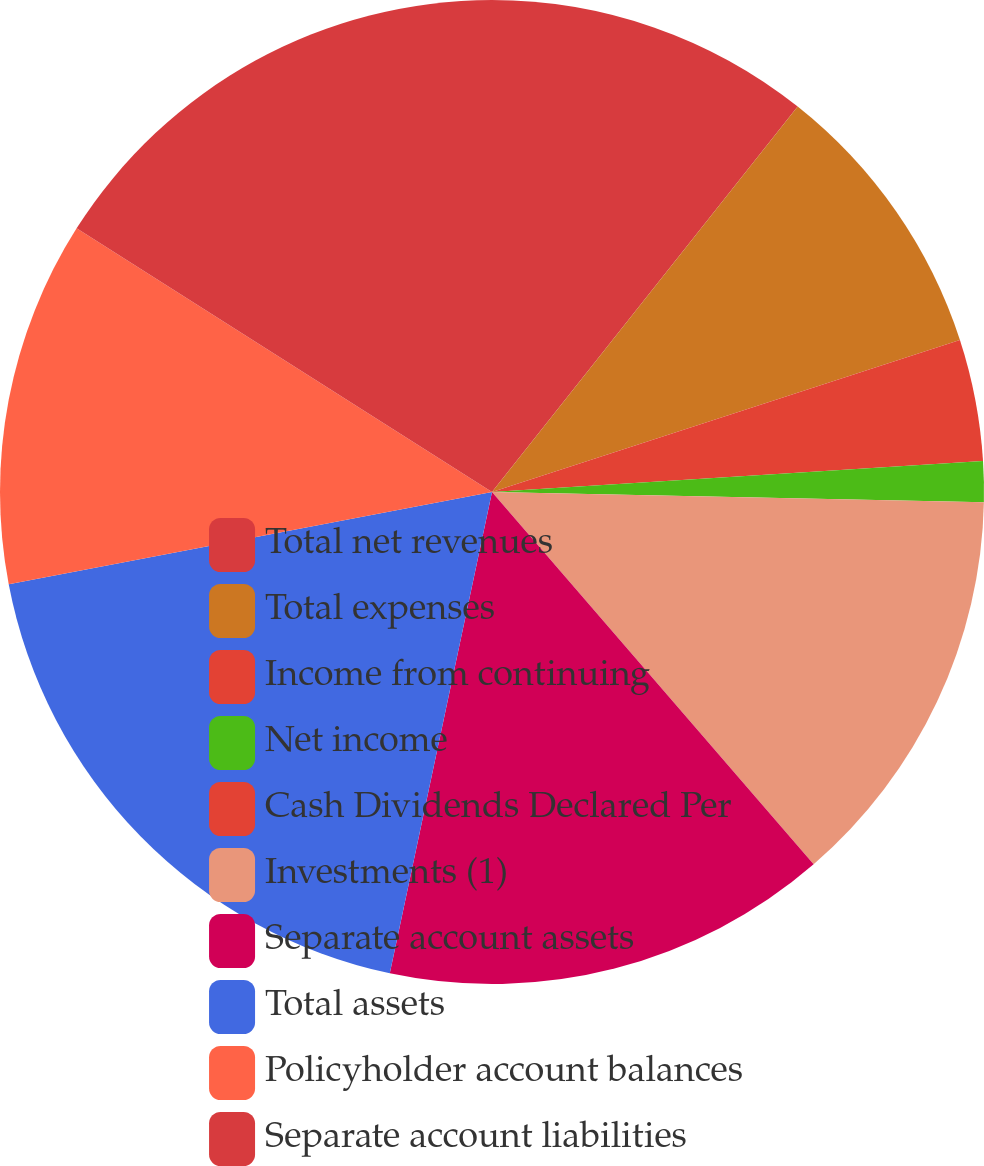<chart> <loc_0><loc_0><loc_500><loc_500><pie_chart><fcel>Total net revenues<fcel>Total expenses<fcel>Income from continuing<fcel>Net income<fcel>Cash Dividends Declared Per<fcel>Investments (1)<fcel>Separate account assets<fcel>Total assets<fcel>Policyholder account balances<fcel>Separate account liabilities<nl><fcel>10.67%<fcel>9.33%<fcel>4.0%<fcel>1.33%<fcel>0.0%<fcel>13.33%<fcel>14.67%<fcel>18.67%<fcel>12.0%<fcel>16.0%<nl></chart> 